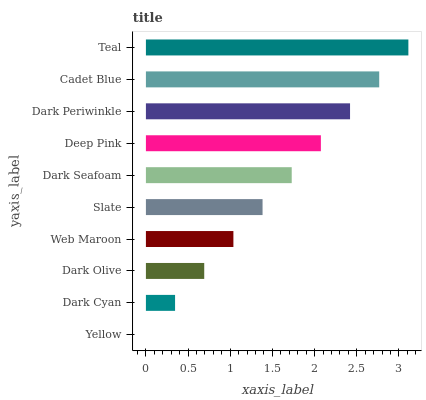Is Yellow the minimum?
Answer yes or no. Yes. Is Teal the maximum?
Answer yes or no. Yes. Is Dark Cyan the minimum?
Answer yes or no. No. Is Dark Cyan the maximum?
Answer yes or no. No. Is Dark Cyan greater than Yellow?
Answer yes or no. Yes. Is Yellow less than Dark Cyan?
Answer yes or no. Yes. Is Yellow greater than Dark Cyan?
Answer yes or no. No. Is Dark Cyan less than Yellow?
Answer yes or no. No. Is Dark Seafoam the high median?
Answer yes or no. Yes. Is Slate the low median?
Answer yes or no. Yes. Is Slate the high median?
Answer yes or no. No. Is Yellow the low median?
Answer yes or no. No. 